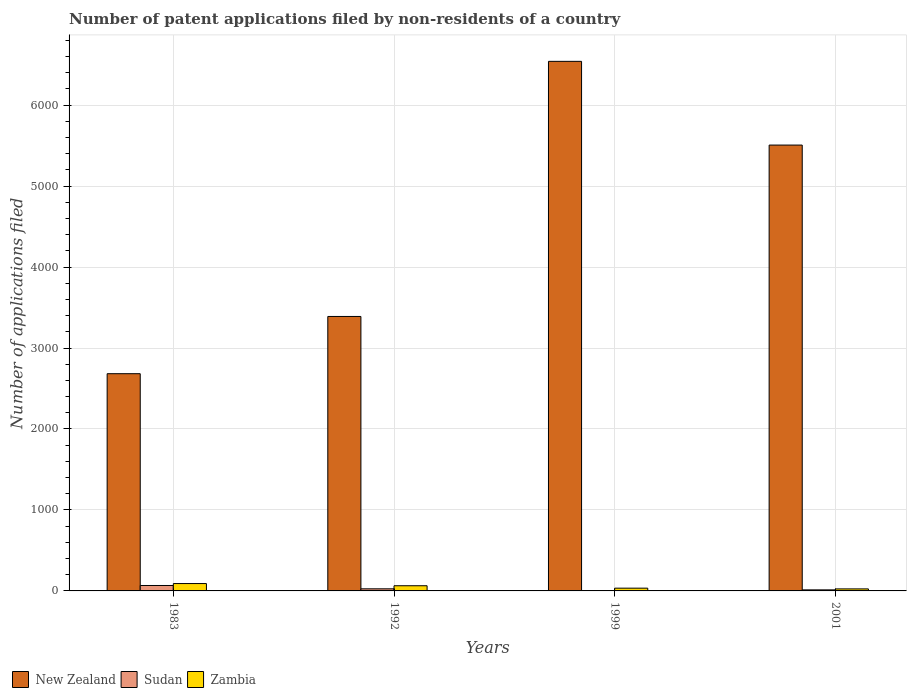How many groups of bars are there?
Keep it short and to the point. 4. Are the number of bars per tick equal to the number of legend labels?
Your response must be concise. Yes. How many bars are there on the 3rd tick from the left?
Give a very brief answer. 3. What is the label of the 1st group of bars from the left?
Give a very brief answer. 1983. Across all years, what is the maximum number of applications filed in New Zealand?
Your answer should be very brief. 6541. In which year was the number of applications filed in New Zealand minimum?
Your answer should be compact. 1983. What is the total number of applications filed in Sudan in the graph?
Your answer should be very brief. 110. What is the difference between the number of applications filed in New Zealand in 1983 and the number of applications filed in Sudan in 1999?
Make the answer very short. 2679. What is the average number of applications filed in New Zealand per year?
Your answer should be compact. 4530.25. In the year 2001, what is the difference between the number of applications filed in Zambia and number of applications filed in Sudan?
Your response must be concise. 12. What is the ratio of the number of applications filed in Sudan in 1983 to that in 1999?
Keep it short and to the point. 16.75. Is the number of applications filed in Zambia in 1992 less than that in 2001?
Your response must be concise. No. What is the difference between the highest and the lowest number of applications filed in New Zealand?
Your answer should be compact. 3858. In how many years, is the number of applications filed in Zambia greater than the average number of applications filed in Zambia taken over all years?
Ensure brevity in your answer.  2. What does the 3rd bar from the left in 1983 represents?
Your response must be concise. Zambia. What does the 1st bar from the right in 1992 represents?
Keep it short and to the point. Zambia. How many years are there in the graph?
Your answer should be compact. 4. Does the graph contain any zero values?
Your response must be concise. No. Does the graph contain grids?
Provide a succinct answer. Yes. How are the legend labels stacked?
Make the answer very short. Horizontal. What is the title of the graph?
Give a very brief answer. Number of patent applications filed by non-residents of a country. What is the label or title of the X-axis?
Your response must be concise. Years. What is the label or title of the Y-axis?
Make the answer very short. Number of applications filed. What is the Number of applications filed of New Zealand in 1983?
Give a very brief answer. 2683. What is the Number of applications filed in Sudan in 1983?
Provide a succinct answer. 67. What is the Number of applications filed of Zambia in 1983?
Your response must be concise. 91. What is the Number of applications filed in New Zealand in 1992?
Provide a short and direct response. 3390. What is the Number of applications filed of Sudan in 1992?
Provide a short and direct response. 26. What is the Number of applications filed in New Zealand in 1999?
Your answer should be very brief. 6541. What is the Number of applications filed of Zambia in 1999?
Your answer should be compact. 34. What is the Number of applications filed of New Zealand in 2001?
Make the answer very short. 5507. Across all years, what is the maximum Number of applications filed of New Zealand?
Make the answer very short. 6541. Across all years, what is the maximum Number of applications filed of Zambia?
Keep it short and to the point. 91. Across all years, what is the minimum Number of applications filed of New Zealand?
Provide a succinct answer. 2683. Across all years, what is the minimum Number of applications filed in Zambia?
Offer a very short reply. 25. What is the total Number of applications filed in New Zealand in the graph?
Offer a very short reply. 1.81e+04. What is the total Number of applications filed of Sudan in the graph?
Your answer should be very brief. 110. What is the total Number of applications filed in Zambia in the graph?
Your response must be concise. 214. What is the difference between the Number of applications filed of New Zealand in 1983 and that in 1992?
Make the answer very short. -707. What is the difference between the Number of applications filed of Zambia in 1983 and that in 1992?
Your answer should be compact. 27. What is the difference between the Number of applications filed of New Zealand in 1983 and that in 1999?
Make the answer very short. -3858. What is the difference between the Number of applications filed of Sudan in 1983 and that in 1999?
Offer a very short reply. 63. What is the difference between the Number of applications filed of New Zealand in 1983 and that in 2001?
Your response must be concise. -2824. What is the difference between the Number of applications filed of Zambia in 1983 and that in 2001?
Ensure brevity in your answer.  66. What is the difference between the Number of applications filed in New Zealand in 1992 and that in 1999?
Keep it short and to the point. -3151. What is the difference between the Number of applications filed of Sudan in 1992 and that in 1999?
Offer a terse response. 22. What is the difference between the Number of applications filed in New Zealand in 1992 and that in 2001?
Provide a short and direct response. -2117. What is the difference between the Number of applications filed in Sudan in 1992 and that in 2001?
Ensure brevity in your answer.  13. What is the difference between the Number of applications filed of New Zealand in 1999 and that in 2001?
Offer a very short reply. 1034. What is the difference between the Number of applications filed in Sudan in 1999 and that in 2001?
Keep it short and to the point. -9. What is the difference between the Number of applications filed of New Zealand in 1983 and the Number of applications filed of Sudan in 1992?
Ensure brevity in your answer.  2657. What is the difference between the Number of applications filed of New Zealand in 1983 and the Number of applications filed of Zambia in 1992?
Ensure brevity in your answer.  2619. What is the difference between the Number of applications filed of Sudan in 1983 and the Number of applications filed of Zambia in 1992?
Offer a terse response. 3. What is the difference between the Number of applications filed of New Zealand in 1983 and the Number of applications filed of Sudan in 1999?
Ensure brevity in your answer.  2679. What is the difference between the Number of applications filed in New Zealand in 1983 and the Number of applications filed in Zambia in 1999?
Give a very brief answer. 2649. What is the difference between the Number of applications filed in Sudan in 1983 and the Number of applications filed in Zambia in 1999?
Ensure brevity in your answer.  33. What is the difference between the Number of applications filed in New Zealand in 1983 and the Number of applications filed in Sudan in 2001?
Provide a short and direct response. 2670. What is the difference between the Number of applications filed in New Zealand in 1983 and the Number of applications filed in Zambia in 2001?
Provide a short and direct response. 2658. What is the difference between the Number of applications filed in Sudan in 1983 and the Number of applications filed in Zambia in 2001?
Make the answer very short. 42. What is the difference between the Number of applications filed of New Zealand in 1992 and the Number of applications filed of Sudan in 1999?
Make the answer very short. 3386. What is the difference between the Number of applications filed of New Zealand in 1992 and the Number of applications filed of Zambia in 1999?
Your response must be concise. 3356. What is the difference between the Number of applications filed in Sudan in 1992 and the Number of applications filed in Zambia in 1999?
Offer a very short reply. -8. What is the difference between the Number of applications filed in New Zealand in 1992 and the Number of applications filed in Sudan in 2001?
Offer a very short reply. 3377. What is the difference between the Number of applications filed of New Zealand in 1992 and the Number of applications filed of Zambia in 2001?
Your response must be concise. 3365. What is the difference between the Number of applications filed in Sudan in 1992 and the Number of applications filed in Zambia in 2001?
Make the answer very short. 1. What is the difference between the Number of applications filed in New Zealand in 1999 and the Number of applications filed in Sudan in 2001?
Provide a succinct answer. 6528. What is the difference between the Number of applications filed of New Zealand in 1999 and the Number of applications filed of Zambia in 2001?
Your answer should be compact. 6516. What is the average Number of applications filed of New Zealand per year?
Keep it short and to the point. 4530.25. What is the average Number of applications filed of Zambia per year?
Provide a succinct answer. 53.5. In the year 1983, what is the difference between the Number of applications filed in New Zealand and Number of applications filed in Sudan?
Your answer should be very brief. 2616. In the year 1983, what is the difference between the Number of applications filed in New Zealand and Number of applications filed in Zambia?
Provide a succinct answer. 2592. In the year 1992, what is the difference between the Number of applications filed of New Zealand and Number of applications filed of Sudan?
Your answer should be compact. 3364. In the year 1992, what is the difference between the Number of applications filed in New Zealand and Number of applications filed in Zambia?
Your answer should be compact. 3326. In the year 1992, what is the difference between the Number of applications filed in Sudan and Number of applications filed in Zambia?
Keep it short and to the point. -38. In the year 1999, what is the difference between the Number of applications filed of New Zealand and Number of applications filed of Sudan?
Keep it short and to the point. 6537. In the year 1999, what is the difference between the Number of applications filed in New Zealand and Number of applications filed in Zambia?
Offer a terse response. 6507. In the year 2001, what is the difference between the Number of applications filed of New Zealand and Number of applications filed of Sudan?
Provide a succinct answer. 5494. In the year 2001, what is the difference between the Number of applications filed in New Zealand and Number of applications filed in Zambia?
Your answer should be very brief. 5482. In the year 2001, what is the difference between the Number of applications filed of Sudan and Number of applications filed of Zambia?
Your answer should be very brief. -12. What is the ratio of the Number of applications filed of New Zealand in 1983 to that in 1992?
Your response must be concise. 0.79. What is the ratio of the Number of applications filed of Sudan in 1983 to that in 1992?
Keep it short and to the point. 2.58. What is the ratio of the Number of applications filed of Zambia in 1983 to that in 1992?
Ensure brevity in your answer.  1.42. What is the ratio of the Number of applications filed in New Zealand in 1983 to that in 1999?
Your answer should be compact. 0.41. What is the ratio of the Number of applications filed in Sudan in 1983 to that in 1999?
Your response must be concise. 16.75. What is the ratio of the Number of applications filed of Zambia in 1983 to that in 1999?
Provide a short and direct response. 2.68. What is the ratio of the Number of applications filed of New Zealand in 1983 to that in 2001?
Make the answer very short. 0.49. What is the ratio of the Number of applications filed of Sudan in 1983 to that in 2001?
Keep it short and to the point. 5.15. What is the ratio of the Number of applications filed in Zambia in 1983 to that in 2001?
Ensure brevity in your answer.  3.64. What is the ratio of the Number of applications filed in New Zealand in 1992 to that in 1999?
Make the answer very short. 0.52. What is the ratio of the Number of applications filed of Sudan in 1992 to that in 1999?
Ensure brevity in your answer.  6.5. What is the ratio of the Number of applications filed of Zambia in 1992 to that in 1999?
Give a very brief answer. 1.88. What is the ratio of the Number of applications filed of New Zealand in 1992 to that in 2001?
Provide a succinct answer. 0.62. What is the ratio of the Number of applications filed of Sudan in 1992 to that in 2001?
Make the answer very short. 2. What is the ratio of the Number of applications filed in Zambia in 1992 to that in 2001?
Your answer should be very brief. 2.56. What is the ratio of the Number of applications filed of New Zealand in 1999 to that in 2001?
Ensure brevity in your answer.  1.19. What is the ratio of the Number of applications filed in Sudan in 1999 to that in 2001?
Ensure brevity in your answer.  0.31. What is the ratio of the Number of applications filed of Zambia in 1999 to that in 2001?
Provide a succinct answer. 1.36. What is the difference between the highest and the second highest Number of applications filed of New Zealand?
Offer a very short reply. 1034. What is the difference between the highest and the lowest Number of applications filed in New Zealand?
Offer a very short reply. 3858. What is the difference between the highest and the lowest Number of applications filed of Zambia?
Provide a succinct answer. 66. 